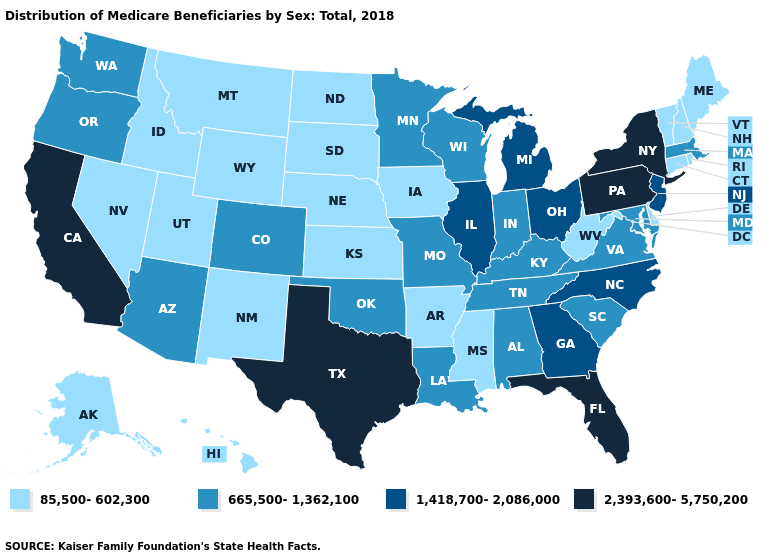Does Connecticut have the lowest value in the Northeast?
Answer briefly. Yes. What is the value of California?
Write a very short answer. 2,393,600-5,750,200. What is the highest value in the USA?
Quick response, please. 2,393,600-5,750,200. Does Texas have the same value as California?
Write a very short answer. Yes. Name the states that have a value in the range 2,393,600-5,750,200?
Be succinct. California, Florida, New York, Pennsylvania, Texas. What is the value of Kansas?
Concise answer only. 85,500-602,300. What is the value of Alaska?
Answer briefly. 85,500-602,300. Name the states that have a value in the range 1,418,700-2,086,000?
Quick response, please. Georgia, Illinois, Michigan, New Jersey, North Carolina, Ohio. Among the states that border Oregon , does California have the lowest value?
Keep it brief. No. Does Montana have a higher value than Michigan?
Keep it brief. No. Does Arkansas have a lower value than Florida?
Be succinct. Yes. Which states have the lowest value in the South?
Answer briefly. Arkansas, Delaware, Mississippi, West Virginia. What is the lowest value in states that border New Jersey?
Answer briefly. 85,500-602,300. Which states have the lowest value in the USA?
Answer briefly. Alaska, Arkansas, Connecticut, Delaware, Hawaii, Idaho, Iowa, Kansas, Maine, Mississippi, Montana, Nebraska, Nevada, New Hampshire, New Mexico, North Dakota, Rhode Island, South Dakota, Utah, Vermont, West Virginia, Wyoming. Name the states that have a value in the range 665,500-1,362,100?
Give a very brief answer. Alabama, Arizona, Colorado, Indiana, Kentucky, Louisiana, Maryland, Massachusetts, Minnesota, Missouri, Oklahoma, Oregon, South Carolina, Tennessee, Virginia, Washington, Wisconsin. 